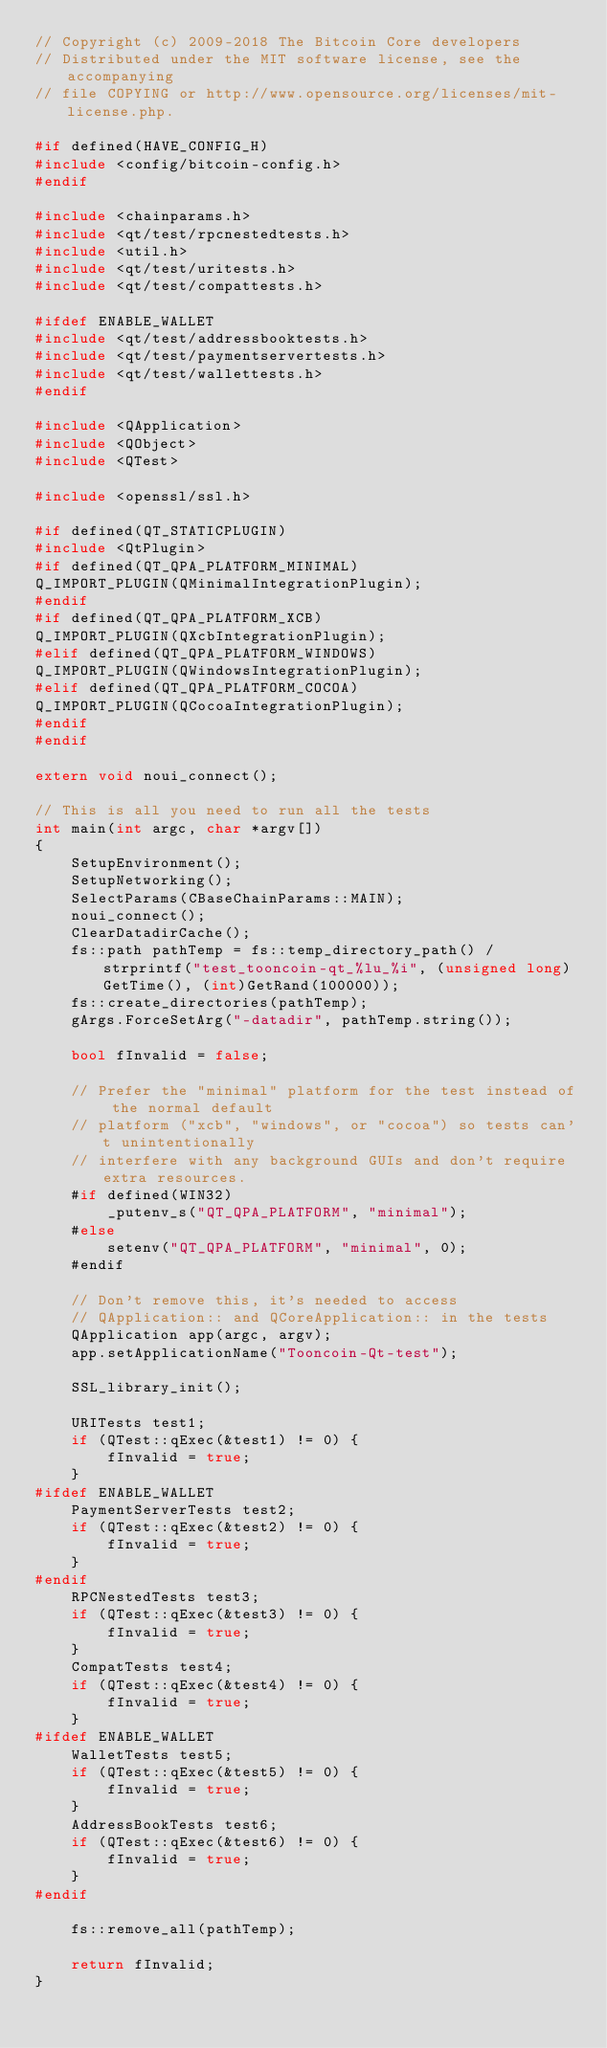Convert code to text. <code><loc_0><loc_0><loc_500><loc_500><_C++_>// Copyright (c) 2009-2018 The Bitcoin Core developers
// Distributed under the MIT software license, see the accompanying
// file COPYING or http://www.opensource.org/licenses/mit-license.php.

#if defined(HAVE_CONFIG_H)
#include <config/bitcoin-config.h>
#endif

#include <chainparams.h>
#include <qt/test/rpcnestedtests.h>
#include <util.h>
#include <qt/test/uritests.h>
#include <qt/test/compattests.h>

#ifdef ENABLE_WALLET
#include <qt/test/addressbooktests.h>
#include <qt/test/paymentservertests.h>
#include <qt/test/wallettests.h>
#endif

#include <QApplication>
#include <QObject>
#include <QTest>

#include <openssl/ssl.h>

#if defined(QT_STATICPLUGIN)
#include <QtPlugin>
#if defined(QT_QPA_PLATFORM_MINIMAL)
Q_IMPORT_PLUGIN(QMinimalIntegrationPlugin);
#endif
#if defined(QT_QPA_PLATFORM_XCB)
Q_IMPORT_PLUGIN(QXcbIntegrationPlugin);
#elif defined(QT_QPA_PLATFORM_WINDOWS)
Q_IMPORT_PLUGIN(QWindowsIntegrationPlugin);
#elif defined(QT_QPA_PLATFORM_COCOA)
Q_IMPORT_PLUGIN(QCocoaIntegrationPlugin);
#endif
#endif

extern void noui_connect();

// This is all you need to run all the tests
int main(int argc, char *argv[])
{
    SetupEnvironment();
    SetupNetworking();
    SelectParams(CBaseChainParams::MAIN);
    noui_connect();
    ClearDatadirCache();
    fs::path pathTemp = fs::temp_directory_path() / strprintf("test_tooncoin-qt_%lu_%i", (unsigned long)GetTime(), (int)GetRand(100000));
    fs::create_directories(pathTemp);
    gArgs.ForceSetArg("-datadir", pathTemp.string());

    bool fInvalid = false;

    // Prefer the "minimal" platform for the test instead of the normal default
    // platform ("xcb", "windows", or "cocoa") so tests can't unintentionally
    // interfere with any background GUIs and don't require extra resources.
    #if defined(WIN32)
        _putenv_s("QT_QPA_PLATFORM", "minimal");
    #else
        setenv("QT_QPA_PLATFORM", "minimal", 0);
    #endif

    // Don't remove this, it's needed to access
    // QApplication:: and QCoreApplication:: in the tests
    QApplication app(argc, argv);
    app.setApplicationName("Tooncoin-Qt-test");

    SSL_library_init();

    URITests test1;
    if (QTest::qExec(&test1) != 0) {
        fInvalid = true;
    }
#ifdef ENABLE_WALLET
    PaymentServerTests test2;
    if (QTest::qExec(&test2) != 0) {
        fInvalid = true;
    }
#endif
    RPCNestedTests test3;
    if (QTest::qExec(&test3) != 0) {
        fInvalid = true;
    }
    CompatTests test4;
    if (QTest::qExec(&test4) != 0) {
        fInvalid = true;
    }
#ifdef ENABLE_WALLET
    WalletTests test5;
    if (QTest::qExec(&test5) != 0) {
        fInvalid = true;
    }
    AddressBookTests test6;
    if (QTest::qExec(&test6) != 0) {
        fInvalid = true;
    }
#endif

    fs::remove_all(pathTemp);

    return fInvalid;
}
</code> 